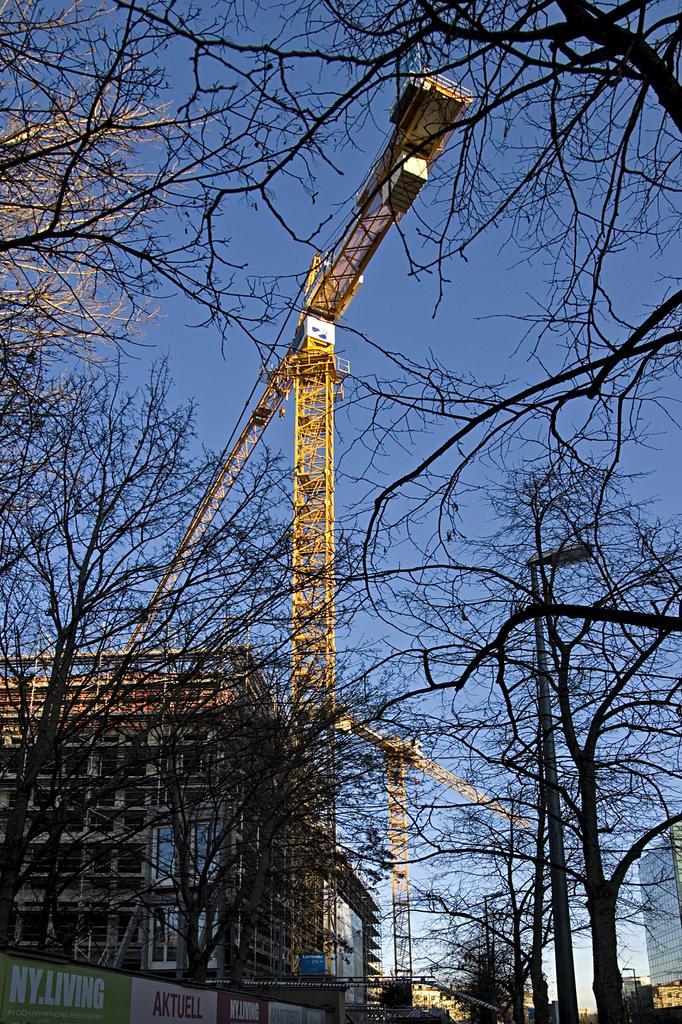Can you describe this image briefly? In this picture we can see some trees on the left and right side. There is a streetlight on the right side. We can see few posts on the left side. There is a board on the building on the left side. We can see few buildings in the background. 